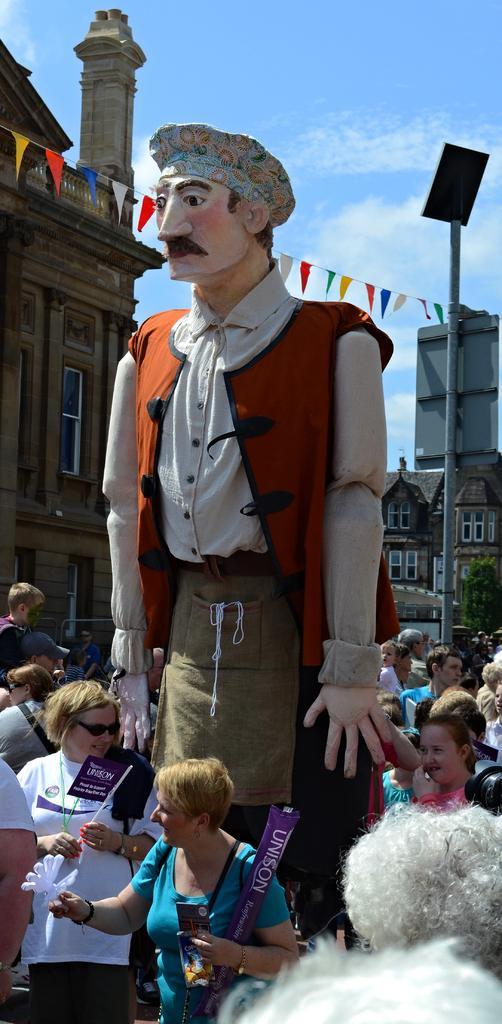Please provide a concise description of this image. In this picture we can see group of people and a statue, in the background we can find few buildings, paper flags, a pole and clouds. 